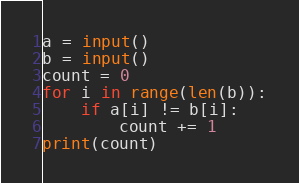Convert code to text. <code><loc_0><loc_0><loc_500><loc_500><_Python_>a = input()
b = input()
count = 0
for i in range(len(b)):
    if a[i] != b[i]:
        count += 1
print(count)</code> 